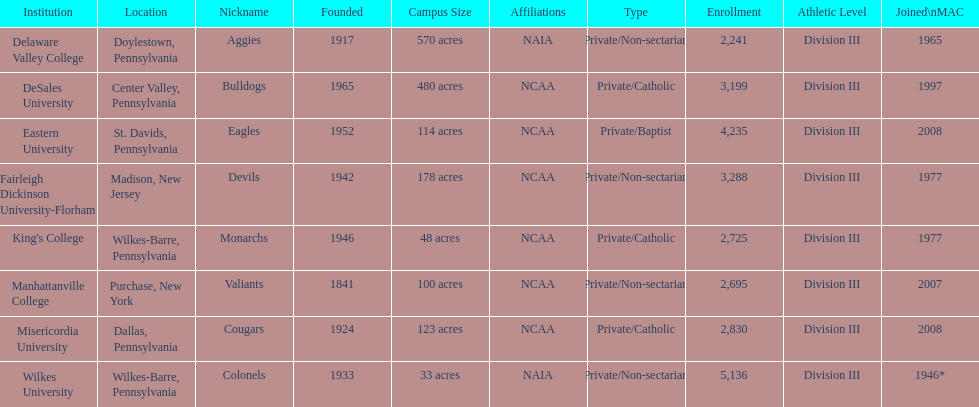How many are enrolled in private/catholic? 8,754. 